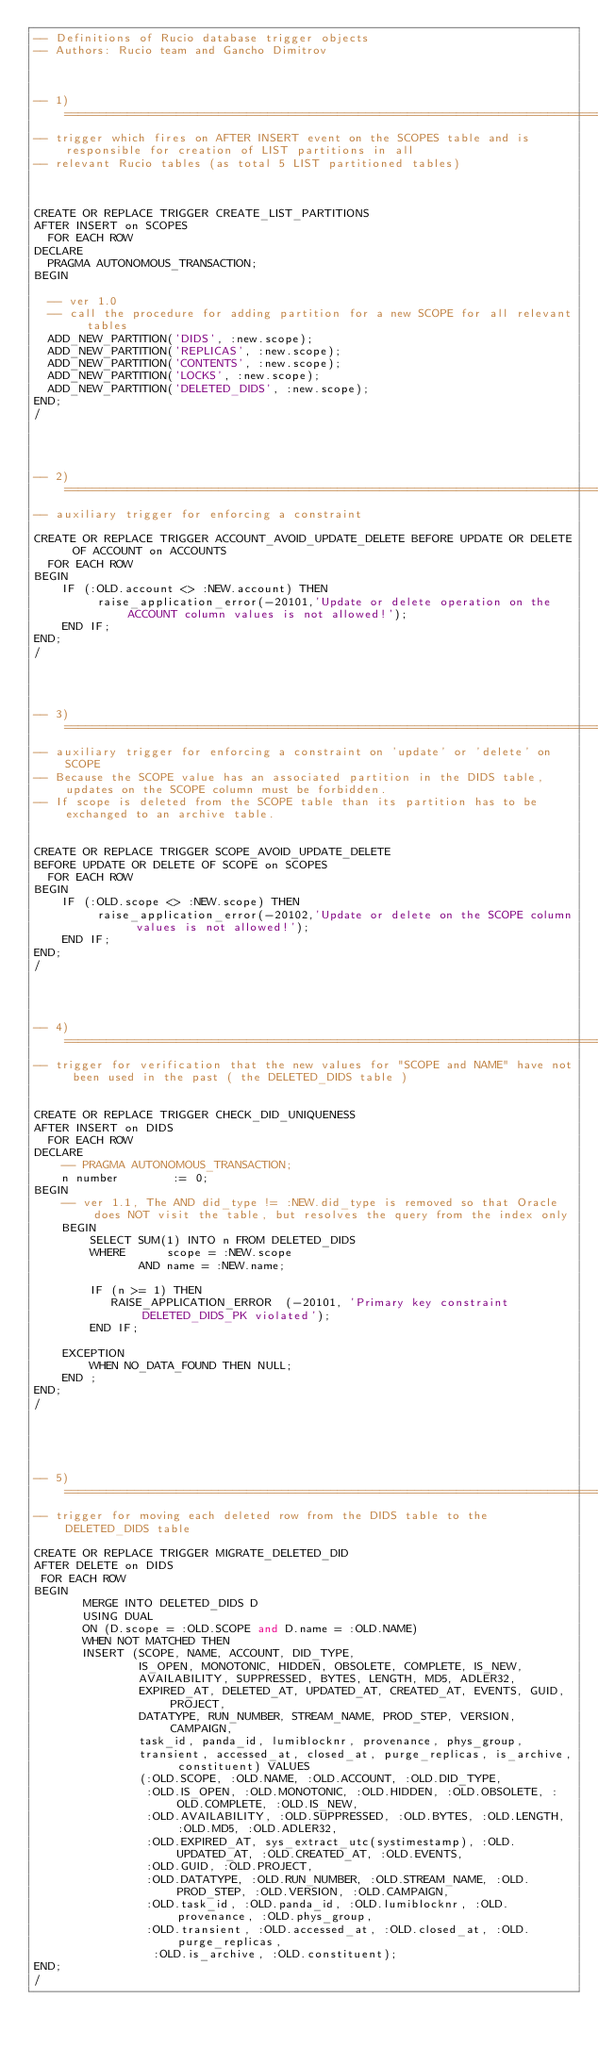<code> <loc_0><loc_0><loc_500><loc_500><_SQL_>-- Definitions of Rucio database trigger objects
-- Authors: Rucio team and Gancho Dimitrov 



-- 1) =================================================================================================================
-- trigger which fires on AFTER INSERT event on the SCOPES table and is responsible for creation of LIST partitions in all
-- relevant Rucio tables (as total 5 LIST partitioned tables)



CREATE OR REPLACE TRIGGER CREATE_LIST_PARTITIONS 
AFTER INSERT on SCOPES
  FOR EACH ROW
DECLARE
	PRAGMA AUTONOMOUS_TRANSACTION;
BEGIN

	-- ver 1.0
	-- call the procedure for adding partition for a new SCOPE for all relevant tables
	ADD_NEW_PARTITION('DIDS', :new.scope);
	ADD_NEW_PARTITION('REPLICAS', :new.scope);
	ADD_NEW_PARTITION('CONTENTS', :new.scope);
	ADD_NEW_PARTITION('LOCKS', :new.scope);
	ADD_NEW_PARTITION('DELETED_DIDS', :new.scope);
END;
/




-- 2) =================================================================================================================
-- auxiliary trigger for enforcing a constraint

CREATE OR REPLACE TRIGGER ACCOUNT_AVOID_UPDATE_DELETE BEFORE UPDATE OR DELETE OF ACCOUNT on ACCOUNTS
  FOR EACH ROW
BEGIN
    IF (:OLD.account <> :NEW.account) THEN
         raise_application_error(-20101,'Update or delete operation on the ACCOUNT column values is not allowed!');
    END IF;
END;
/




-- 3) =================================================================================================================
-- auxiliary trigger for enforcing a constraint on 'update' or 'delete' on SCOPE
-- Because the SCOPE value has an associated partition in the DIDS table, updates on the SCOPE column must be forbidden.
-- If scope is deleted from the SCOPE table than its partition has to be exchanged to an archive table.


CREATE OR REPLACE TRIGGER SCOPE_AVOID_UPDATE_DELETE 
BEFORE UPDATE OR DELETE OF SCOPE on SCOPES
  FOR EACH ROW
BEGIN
    IF (:OLD.scope <> :NEW.scope) THEN
         raise_application_error(-20102,'Update or delete on the SCOPE column values is not allowed!');
    END IF;
END;
/




-- 4) =================================================================================================================
-- trigger for verification that the new values for "SCOPE and NAME" have not been used in the past ( the DELETED_DIDS table )


CREATE OR REPLACE TRIGGER CHECK_DID_UNIQUENESS 
AFTER INSERT on DIDS
  FOR EACH ROW
DECLARE
    -- PRAGMA AUTONOMOUS_TRANSACTION;
    n number        := 0;
BEGIN
    -- ver 1.1, The AND did_type != :NEW.did_type is removed so that Oracle does NOT visit the table, but resolves the query from the index only
    BEGIN
        SELECT SUM(1) INTO n FROM DELETED_DIDS
        WHERE      scope = :NEW.scope
               AND name = :NEW.name;

        IF (n >= 1) THEN
           RAISE_APPLICATION_ERROR  (-20101, 'Primary key constraint DELETED_DIDS_PK violated');
        END IF;

    EXCEPTION
        WHEN NO_DATA_FOUND THEN NULL;
    END ;
END;
/





-- 5) =================================================================================================================
-- trigger for moving each deleted row from the DIDS table to the DELETED_DIDS table

CREATE OR REPLACE TRIGGER MIGRATE_DELETED_DID 
AFTER DELETE on DIDS
 FOR EACH ROW
BEGIN
       MERGE INTO DELETED_DIDS D
       USING DUAL
       ON (D.scope = :OLD.SCOPE and D.name = :OLD.NAME)
       WHEN NOT MATCHED THEN
       INSERT (SCOPE, NAME, ACCOUNT, DID_TYPE,
               IS_OPEN, MONOTONIC, HIDDEN, OBSOLETE, COMPLETE, IS_NEW,
               AVAILABILITY, SUPPRESSED, BYTES, LENGTH, MD5, ADLER32,
               EXPIRED_AT, DELETED_AT, UPDATED_AT, CREATED_AT, EVENTS, GUID, PROJECT,
               DATATYPE, RUN_NUMBER, STREAM_NAME, PROD_STEP, VERSION, CAMPAIGN,
               task_id, panda_id, lumiblocknr, provenance, phys_group,
               transient, accessed_at, closed_at, purge_replicas, is_archive, constituent) VALUES
               (:OLD.SCOPE, :OLD.NAME, :OLD.ACCOUNT, :OLD.DID_TYPE,
                :OLD.IS_OPEN, :OLD.MONOTONIC, :OLD.HIDDEN, :OLD.OBSOLETE, :OLD.COMPLETE, :OLD.IS_NEW,
                :OLD.AVAILABILITY, :OLD.SUPPRESSED, :OLD.BYTES, :OLD.LENGTH, :OLD.MD5, :OLD.ADLER32,
                :OLD.EXPIRED_AT, sys_extract_utc(systimestamp), :OLD.UPDATED_AT, :OLD.CREATED_AT, :OLD.EVENTS,
                :OLD.GUID, :OLD.PROJECT,
                :OLD.DATATYPE, :OLD.RUN_NUMBER, :OLD.STREAM_NAME, :OLD.PROD_STEP, :OLD.VERSION, :OLD.CAMPAIGN,
                :OLD.task_id, :OLD.panda_id, :OLD.lumiblocknr, :OLD.provenance, :OLD.phys_group,
                :OLD.transient, :OLD.accessed_at, :OLD.closed_at, :OLD.purge_replicas,
                 :OLD.is_archive, :OLD.constituent);
END;
/
</code> 